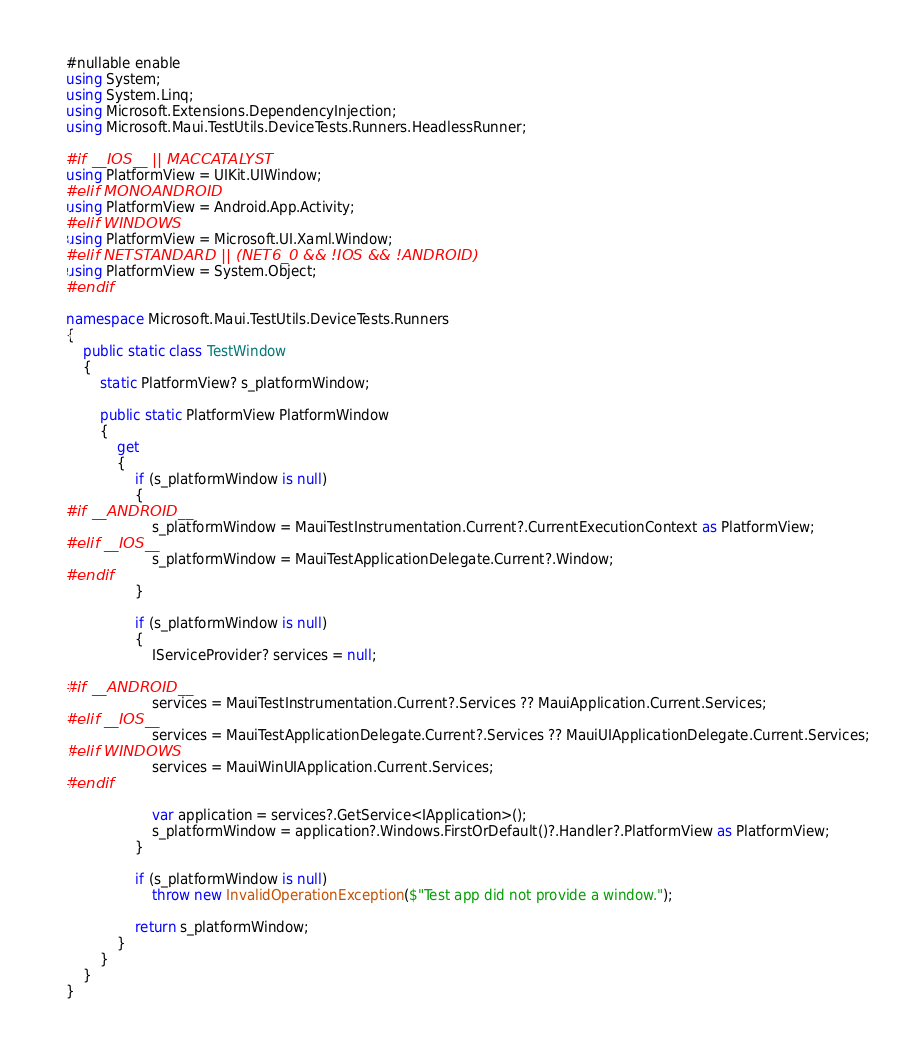<code> <loc_0><loc_0><loc_500><loc_500><_C#_>#nullable enable
using System;
using System.Linq;
using Microsoft.Extensions.DependencyInjection;
using Microsoft.Maui.TestUtils.DeviceTests.Runners.HeadlessRunner;

#if __IOS__ || MACCATALYST
using PlatformView = UIKit.UIWindow;
#elif MONOANDROID
using PlatformView = Android.App.Activity;
#elif WINDOWS
using PlatformView = Microsoft.UI.Xaml.Window;
#elif NETSTANDARD || (NET6_0 && !IOS && !ANDROID)
using PlatformView = System.Object;
#endif

namespace Microsoft.Maui.TestUtils.DeviceTests.Runners
{
	public static class TestWindow
	{
		static PlatformView? s_platformWindow;

		public static PlatformView PlatformWindow
		{
			get
			{
				if (s_platformWindow is null)
				{
#if __ANDROID__
					s_platformWindow = MauiTestInstrumentation.Current?.CurrentExecutionContext as PlatformView;
#elif __IOS__
					s_platformWindow = MauiTestApplicationDelegate.Current?.Window;
#endif
				}

				if (s_platformWindow is null)
				{
					IServiceProvider? services = null;

#if __ANDROID__
					services = MauiTestInstrumentation.Current?.Services ?? MauiApplication.Current.Services;
#elif __IOS__
					services = MauiTestApplicationDelegate.Current?.Services ?? MauiUIApplicationDelegate.Current.Services;
#elif WINDOWS
					services = MauiWinUIApplication.Current.Services;
#endif

					var application = services?.GetService<IApplication>();
					s_platformWindow = application?.Windows.FirstOrDefault()?.Handler?.PlatformView as PlatformView;
				}

				if (s_platformWindow is null)
					throw new InvalidOperationException($"Test app did not provide a window.");

				return s_platformWindow;
			}
		}
	}
}</code> 